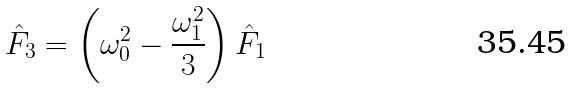Convert formula to latex. <formula><loc_0><loc_0><loc_500><loc_500>\hat { F } _ { 3 } = \left ( \omega ^ { 2 } _ { 0 } - \frac { \omega _ { 1 } ^ { 2 } } { 3 } \right ) \hat { F } _ { 1 }</formula> 